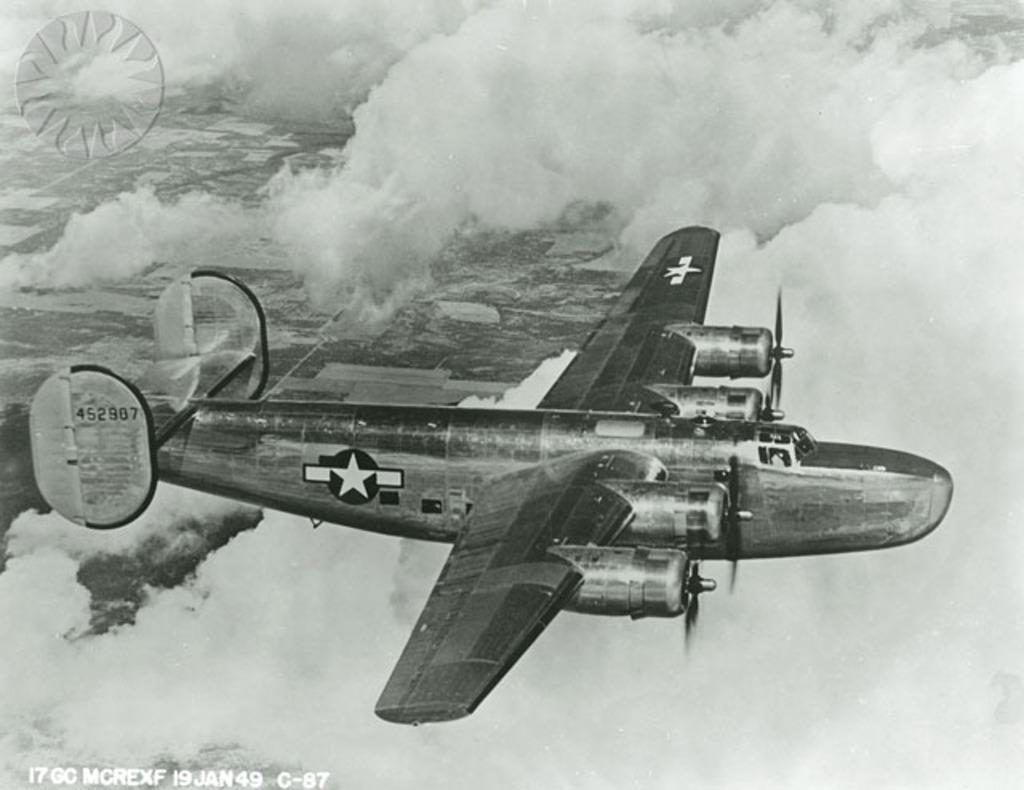Provide a one-sentence caption for the provided image. A United States military plane flies on January 19, 1949. 